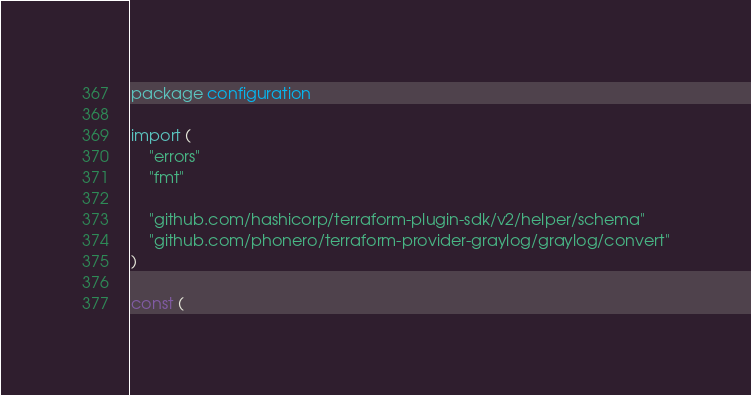<code> <loc_0><loc_0><loc_500><loc_500><_Go_>package configuration

import (
	"errors"
	"fmt"

	"github.com/hashicorp/terraform-plugin-sdk/v2/helper/schema"
	"github.com/phonero/terraform-provider-graylog/graylog/convert"
)

const (</code> 